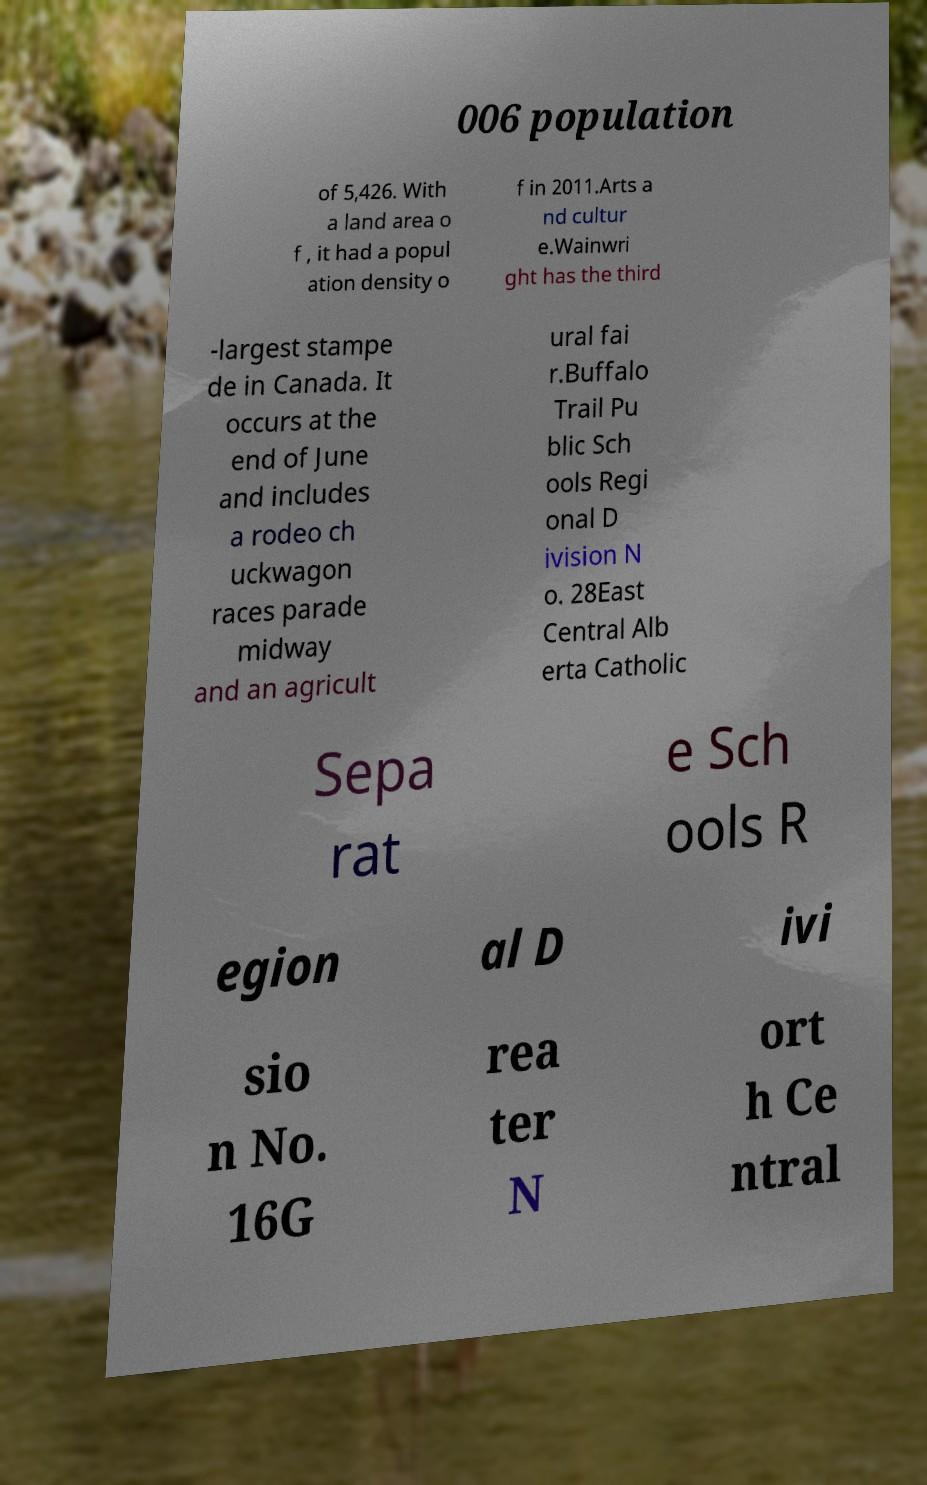Can you read and provide the text displayed in the image?This photo seems to have some interesting text. Can you extract and type it out for me? 006 population of 5,426. With a land area o f , it had a popul ation density o f in 2011.Arts a nd cultur e.Wainwri ght has the third -largest stampe de in Canada. It occurs at the end of June and includes a rodeo ch uckwagon races parade midway and an agricult ural fai r.Buffalo Trail Pu blic Sch ools Regi onal D ivision N o. 28East Central Alb erta Catholic Sepa rat e Sch ools R egion al D ivi sio n No. 16G rea ter N ort h Ce ntral 